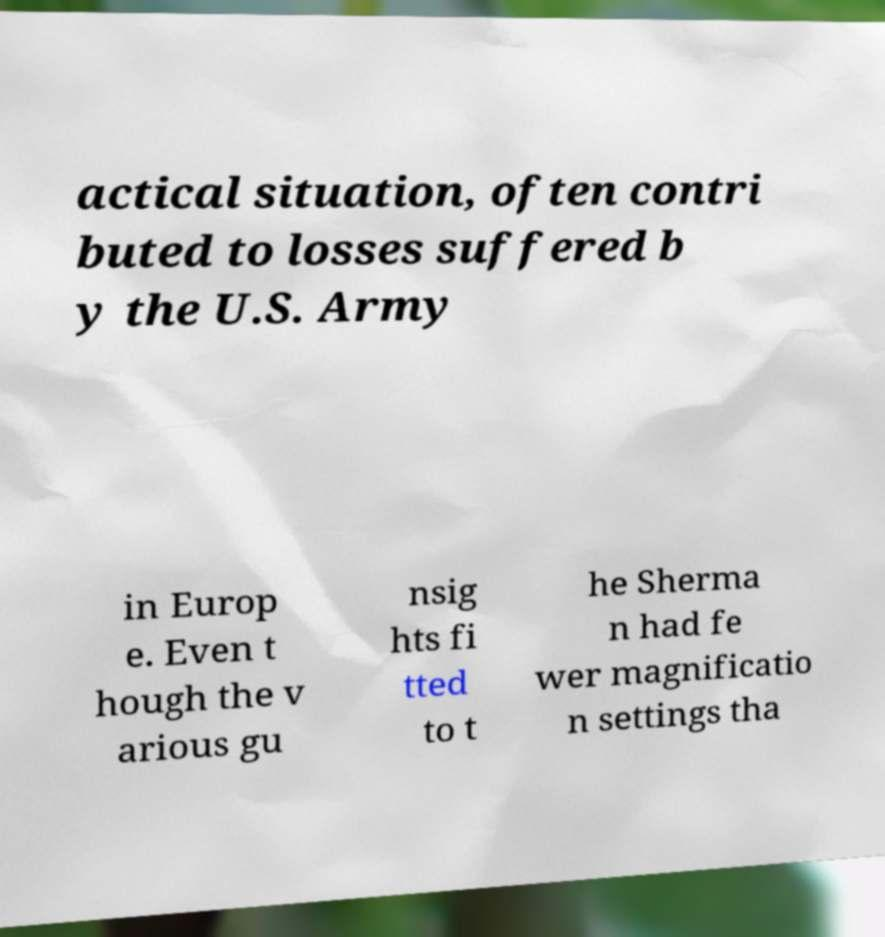Please identify and transcribe the text found in this image. actical situation, often contri buted to losses suffered b y the U.S. Army in Europ e. Even t hough the v arious gu nsig hts fi tted to t he Sherma n had fe wer magnificatio n settings tha 